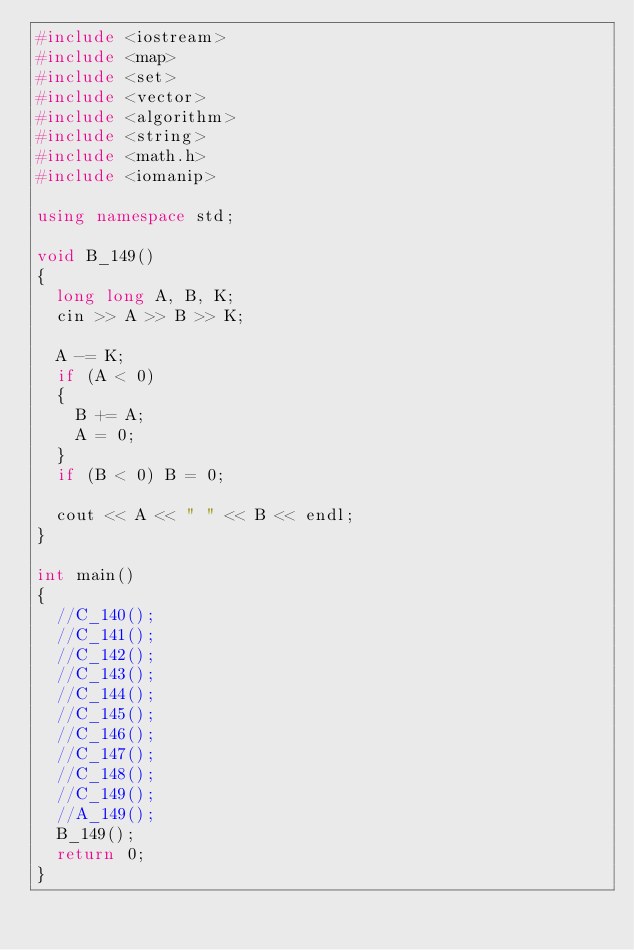Convert code to text. <code><loc_0><loc_0><loc_500><loc_500><_C++_>#include <iostream>
#include <map>
#include <set>
#include <vector>
#include <algorithm>
#include <string>
#include <math.h>
#include <iomanip>

using namespace std;

void B_149()
{
  long long A, B, K;
  cin >> A >> B >> K;

  A -= K;
  if (A < 0)
  {
    B += A;
    A = 0;
  }
  if (B < 0) B = 0;

  cout << A << " " << B << endl;
}

int main()
{
  //C_140();
  //C_141();
  //C_142();
  //C_143();
  //C_144();
  //C_145();
  //C_146();
  //C_147();
  //C_148();
  //C_149();
  //A_149();
  B_149();
  return 0;
}
</code> 